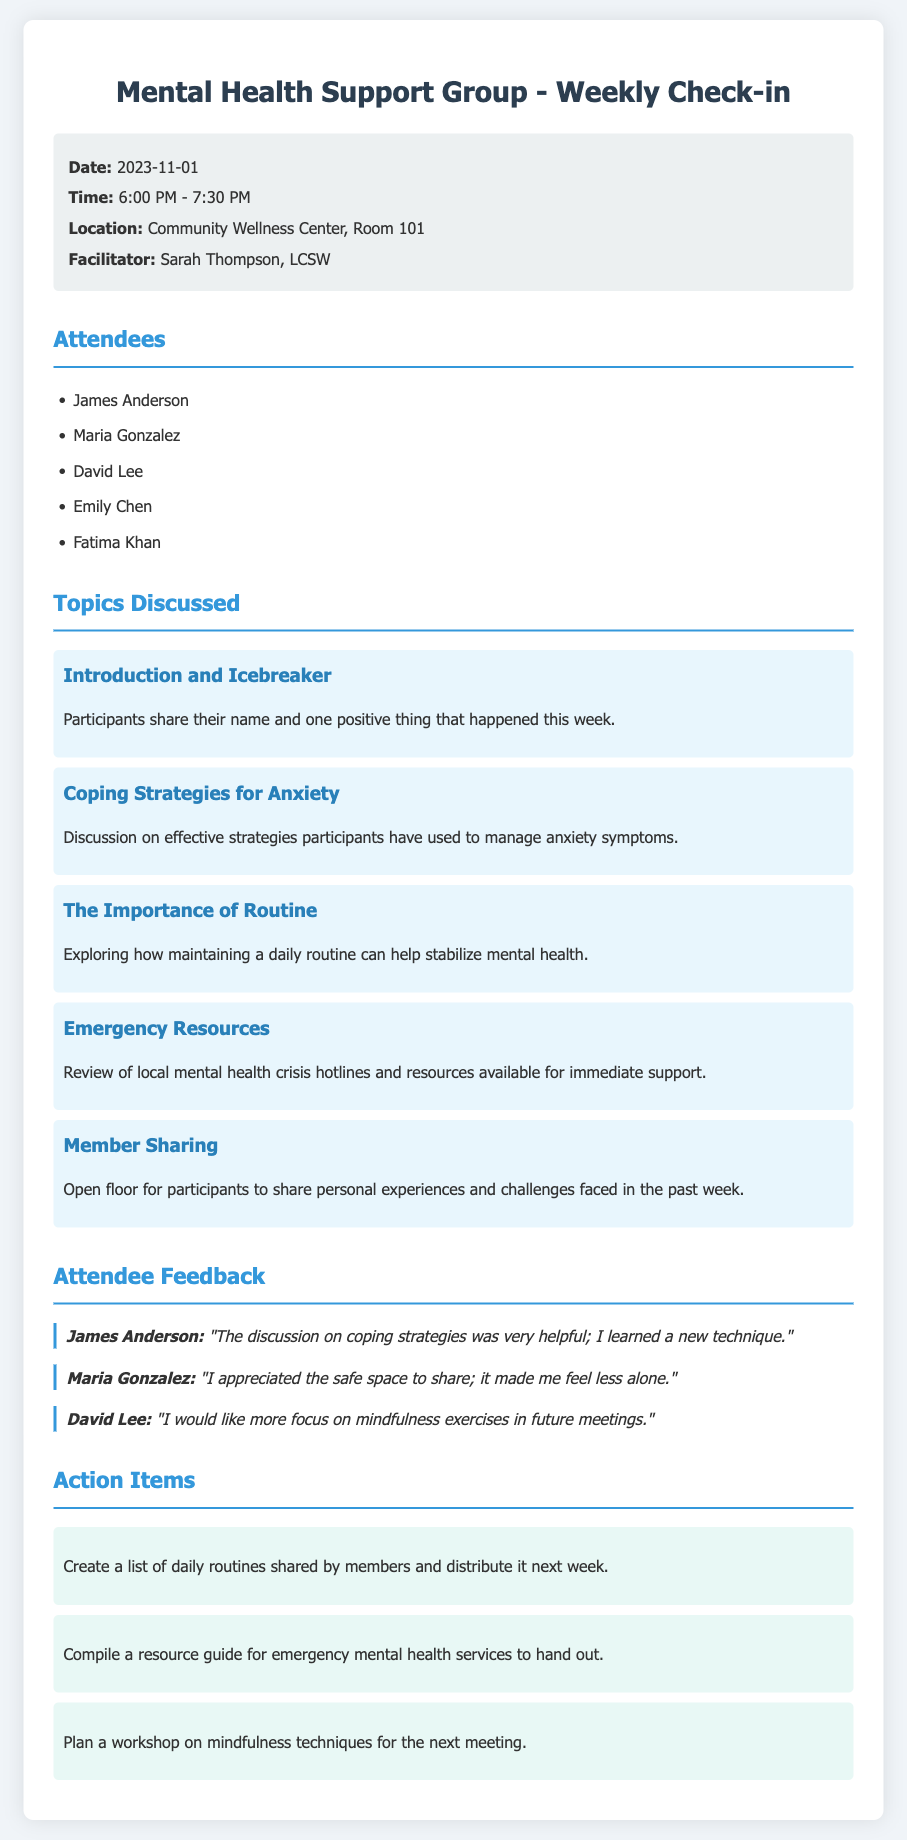what is the date of the meeting? The date of the meeting is specified in the document's info section.
Answer: 2023-11-01 who is the facilitator of the meeting? The facilitator is mentioned in the info section of the document.
Answer: Sarah Thompson, LCSW how many attendees were present? Counting the names listed under the attendees section gives the total number of participants.
Answer: 5 what was one of the coping strategies discussed? The document lists specific topics discussed, including coping strategies.
Answer: Coping Strategies for Anxiety which attendee appreciated the safe space to share? The feedback section lists attendees and their comments.
Answer: Maria Gonzalez what action item involves mindfulness techniques? The action items section specifies plans for future meetings.
Answer: Plan a workshop on mindfulness techniques for the next meeting what resource was reviewed in relation to emergencies? The document mentions specific topics discussed including emergency resources.
Answer: Emergency Resources which attendee wants more focus on mindfulness exercises? The feedback from the attendees indicates their individual preferences.
Answer: David Lee what is the location of the meeting? The location is mentioned in the info section at the beginning of the document.
Answer: Community Wellness Center, Room 101 